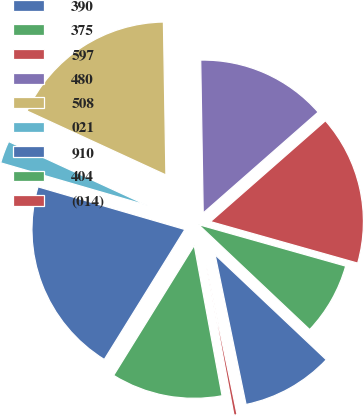<chart> <loc_0><loc_0><loc_500><loc_500><pie_chart><fcel>390<fcel>375<fcel>597<fcel>480<fcel>508<fcel>021<fcel>910<fcel>404<fcel>(014)<nl><fcel>9.71%<fcel>7.67%<fcel>15.84%<fcel>13.8%<fcel>17.87%<fcel>2.37%<fcel>20.67%<fcel>11.75%<fcel>0.33%<nl></chart> 